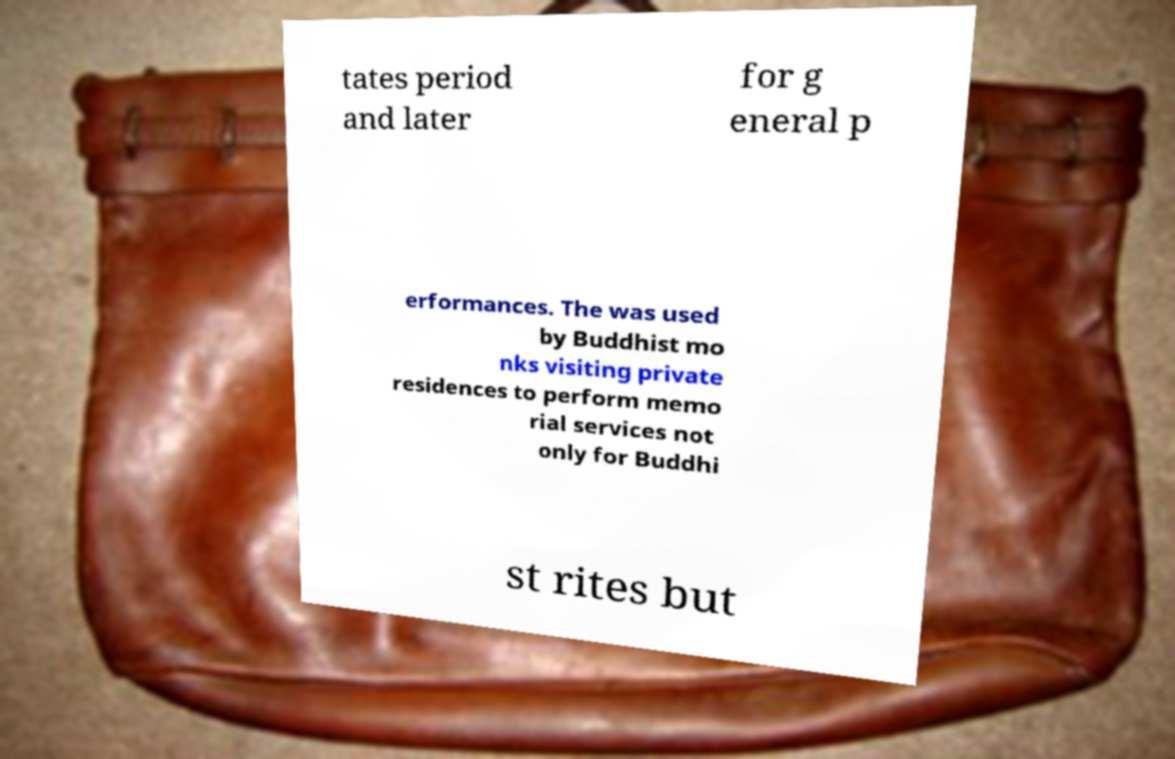Could you assist in decoding the text presented in this image and type it out clearly? tates period and later for g eneral p erformances. The was used by Buddhist mo nks visiting private residences to perform memo rial services not only for Buddhi st rites but 